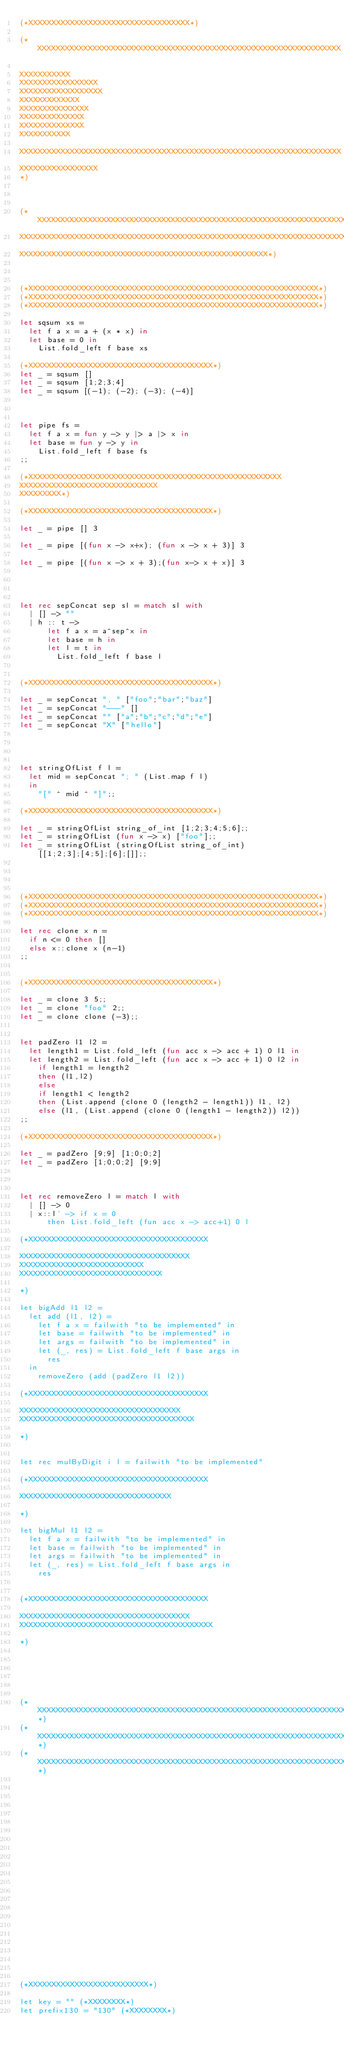<code> <loc_0><loc_0><loc_500><loc_500><_OCaml_>(*XXXXXXXXXXXXXXXXXXXXXXXXXXXXXXXXXXX*)

(*XXXXXXXXXXXXXXXXXXXXXXXXXXXXXXXXXXXXXXXXXXXXXXXXXXXXXXXXXXXXXXXXXX

XXXXXXXXXXX
XXXXXXXXXXXXXXXXX
XXXXXXXXXXXXXXXXXX
XXXXXXXXXXXXX
XXXXXXXXXXXXXXX
XXXXXXXXXXXXXX
XXXXXXXXXXXXXX
XXXXXXXXXXX

XXXXXXXXXXXXXXXXXXXXXXXXXXXXXXXXXXXXXXXXXXXXXXXXXXXXXXXXXXXXXXXXXXXXXX
XXXXXXXXXXXXXXXXX
*)



(*XXXXXXXXXXXXXXXXXXXXXXXXXXXXXXXXXXXXXXXXXXXXXXXXXXXXXXXXXXXXXXXXXXXXXXXXXXX
XXXXXXXXXXXXXXXXXXXXXXXXXXXXXXXXXXXXXXXXXXXXXXXXXXXXXXXXXXXXXXXXXXXXXXXXXXX
XXXXXXXXXXXXXXXXXXXXXXXXXXXXXXXXXXXXXXXXXXXXXXXXXXXXXX*)



(*XXXXXXXXXXXXXXXXXXXXXXXXXXXXXXXXXXXXXXXXXXXXXXXXXXXXXXXXXXXXXXX*)
(*XXXXXXXXXXXXXXXXXXXXXXXXXXXXXXXXXXXXXXXXXXXXXXXXXXXXXXXXXXXXXXX*)
(*XXXXXXXXXXXXXXXXXXXXXXXXXXXXXXXXXXXXXXXXXXXXXXXXXXXXXXXXXXXXXXX*)

let sqsum xs = 
  let f a x = a + (x * x) in
  let base = 0 in
    List.fold_left f base xs

(*XXXXXXXXXXXXXXXXXXXXXXXXXXXXXXXXXXXXXXXX*)
let _ = sqsum []
let _ = sqsum [1;2;3;4]
let _ = sqsum [(-1); (-2); (-3); (-4)]



let pipe fs = 
  let f a x = fun y -> y |> a |> x in
  let base = fun y -> y in
    List.fold_left f base fs
;;

(*XXXXXXXXXXXXXXXXXXXXXXXXXXXXXXXXXXXXXXXXXXXXXXXXXXXXXXX
XXXXXXXXXXXXXXXXXXXXXXXXXXXXXX
XXXXXXXXX*)

(*XXXXXXXXXXXXXXXXXXXXXXXXXXXXXXXXXXXXXXXX*)

let _ = pipe [] 3

let _ = pipe [(fun x -> x+x); (fun x -> x + 3)] 3

let _ = pipe [(fun x -> x + 3);(fun x-> x + x)] 3




let rec sepConcat sep sl = match sl with 
  | [] -> ""
  | h :: t -> 
      let f a x = a^sep^x in
      let base = h in
      let l = t in
        List.fold_left f base l


(*XXXXXXXXXXXXXXXXXXXXXXXXXXXXXXXXXXXXXXXX*)

let _ = sepConcat ", " ["foo";"bar";"baz"]
let _ = sepConcat "---" []
let _ = sepConcat "" ["a";"b";"c";"d";"e"]
let _ = sepConcat "X" ["hello"]




let stringOfList f l = 
  let mid = sepConcat "; " (List.map f l) 
  in 
    "[" ^ mid ^ "]";;

(*XXXXXXXXXXXXXXXXXXXXXXXXXXXXXXXXXXXXXXXX*)

let _ = stringOfList string_of_int [1;2;3;4;5;6];;
let _ = stringOfList (fun x -> x) ["foo"];;
let _ = stringOfList (stringOfList string_of_int) [[1;2;3];[4;5];[6];[]];;




(*XXXXXXXXXXXXXXXXXXXXXXXXXXXXXXXXXXXXXXXXXXXXXXXXXXXXXXXXXXXXXXX*)
(*XXXXXXXXXXXXXXXXXXXXXXXXXXXXXXXXXXXXXXXXXXXXXXXXXXXXXXXXXXXXXXX*)
(*XXXXXXXXXXXXXXXXXXXXXXXXXXXXXXXXXXXXXXXXXXXXXXXXXXXXXXXXXXXXXXX*)

let rec clone x n = 
  if n <= 0 then []
  else x::clone x (n-1)
;;


(*XXXXXXXXXXXXXXXXXXXXXXXXXXXXXXXXXXXXXXXX*)

let _ = clone 3 5;;
let _ = clone "foo" 2;; 
let _ = clone clone (-3);;


let padZero l1 l2 = 
  let length1 = List.fold_left (fun acc x -> acc + 1) 0 l1 in
  let length2 = List.fold_left (fun acc x -> acc + 1) 0 l2 in
    if length1 = length2 
    then (l1,l2)
    else 
    if length1 < length2
    then (List.append (clone 0 (length2 - length1)) l1, l2)
    else (l1, (List.append (clone 0 (length1 - length2)) l2))
;;

(*XXXXXXXXXXXXXXXXXXXXXXXXXXXXXXXXXXXXXXXX*)

let _ = padZero [9;9] [1;0;0;2]
let _ = padZero [1;0;0;2] [9;9] 



let rec removeZero l = match l with
  | [] -> 0
  | x::l' -> if x = 0
      then List.fold_left (fun acc x -> acc+1) 0 l

(*XXXXXXXXXXXXXXXXXXXXXXXXXXXXXXXXXXXXXXX

XXXXXXXXXXXXXXXXXXXXXXXXXXXXXXXXXXXXX
XXXXXXXXXXXXXXXXXXXXXXXXXXX
XXXXXXXXXXXXXXXXXXXXXXXXXXXXXXX

*)

let bigAdd l1 l2 = 
  let add (l1, l2) = 
    let f a x = failwith "to be implemented" in
    let base = failwith "to be implemented" in
    let args = failwith "to be implemented" in
    let (_, res) = List.fold_left f base args in
      res
  in 
    removeZero (add (padZero l1 l2))

(*XXXXXXXXXXXXXXXXXXXXXXXXXXXXXXXXXXXXXXX

XXXXXXXXXXXXXXXXXXXXXXXXXXXXXXXXXXX
XXXXXXXXXXXXXXXXXXXXXXXXXXXXXXXXXXXXXX

*)


let rec mulByDigit i l = failwith "to be implemented"

(*XXXXXXXXXXXXXXXXXXXXXXXXXXXXXXXXXXXXXXX

XXXXXXXXXXXXXXXXXXXXXXXXXXXXXXXXX

*)

let bigMul l1 l2 = 
  let f a x = failwith "to be implemented" in
  let base = failwith "to be implemented" in
  let args = failwith "to be implemented" in
  let (_, res) = List.fold_left f base args in
    res


(*XXXXXXXXXXXXXXXXXXXXXXXXXXXXXXXXXXXXXXX

XXXXXXXXXXXXXXXXXXXXXXXXXXXXXXXXXXXXX
XXXXXXXXXXXXXXXXXXXXXXXXXXXXXXXXXXXXXXXXXX

*)






(*XXXXXXXXXXXXXXXXXXXXXXXXXXXXXXXXXXXXXXXXXXXXXXXXXXXXXXXXXXXXXXXXXXXXXXXXXXXXX*)
(*XXXXXXXXXXXXXXXXXXXXXXXXXXXXXXXXXXXXXXXXXXXXXXXXXXXXXXXXXXXXXXXXXXXXXXXXXXXXX*)
(*XXXXXXXXXXXXXXXXXXXXXXXXXXXXXXXXXXXXXXXXXXXXXXXXXXXXXXXXXXXXXXXXXXXXXXXXXXXXX*)
























(*XXXXXXXXXXXXXXXXXXXXXXXXXX*)

let key = "" (*XXXXXXXX*)
let prefix130 = "130" (*XXXXXXXX*)</code> 